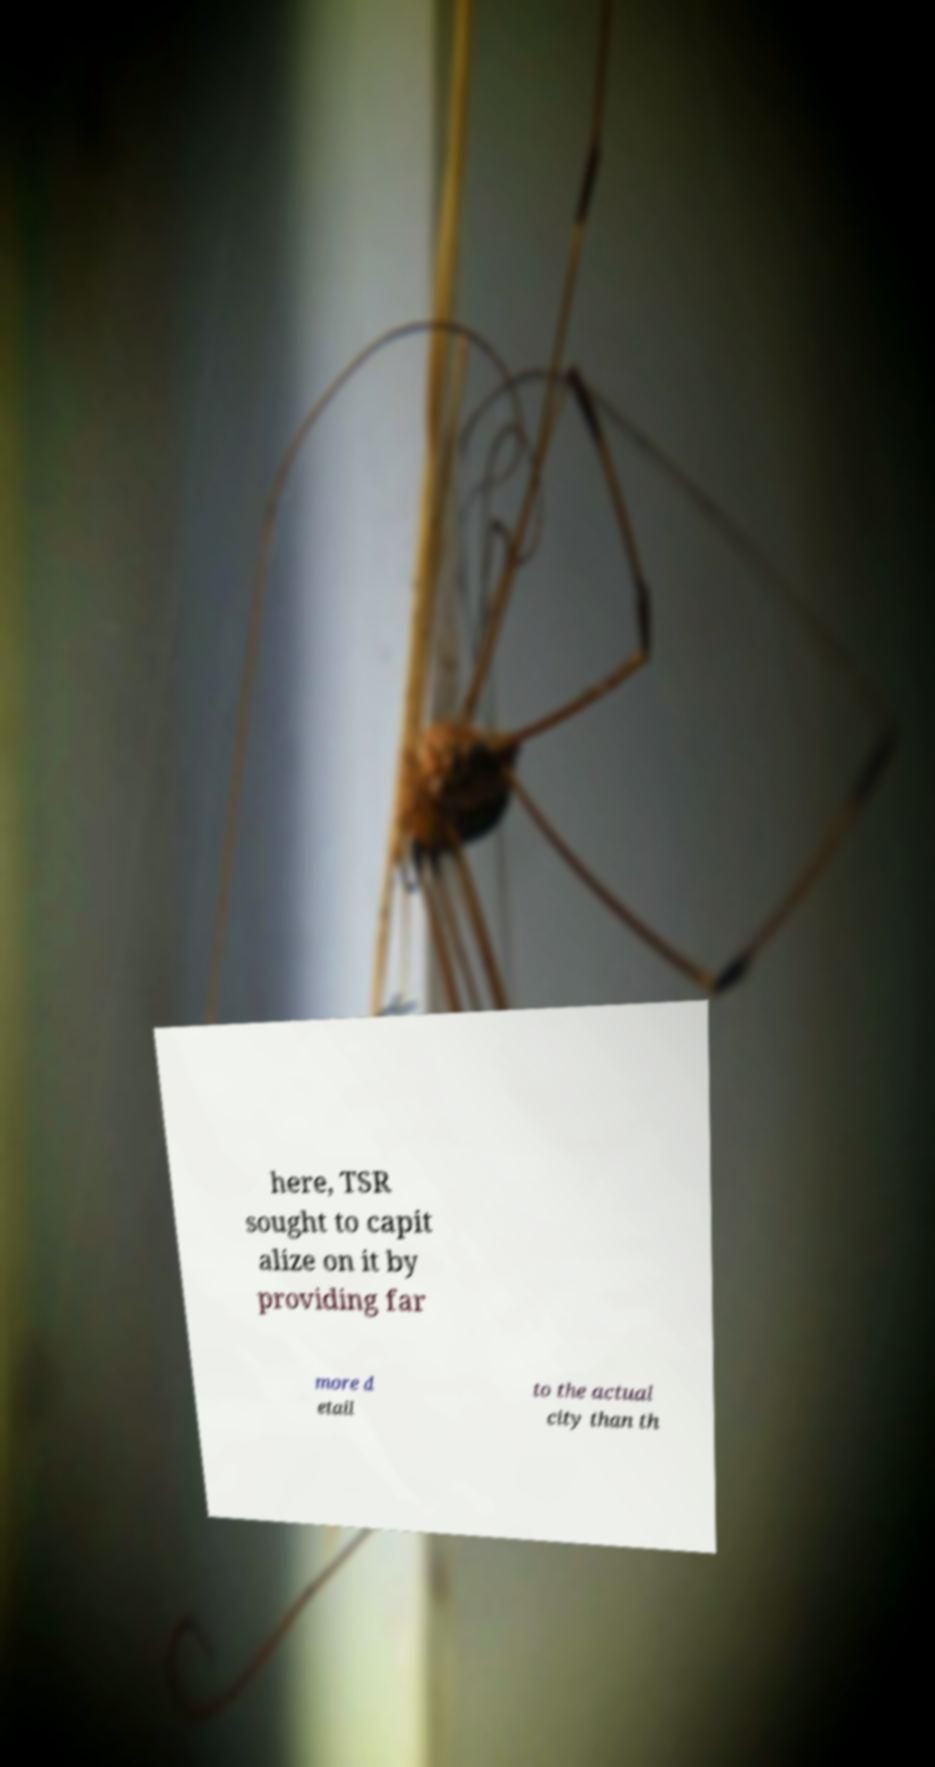Please read and relay the text visible in this image. What does it say? here, TSR sought to capit alize on it by providing far more d etail to the actual city than th 